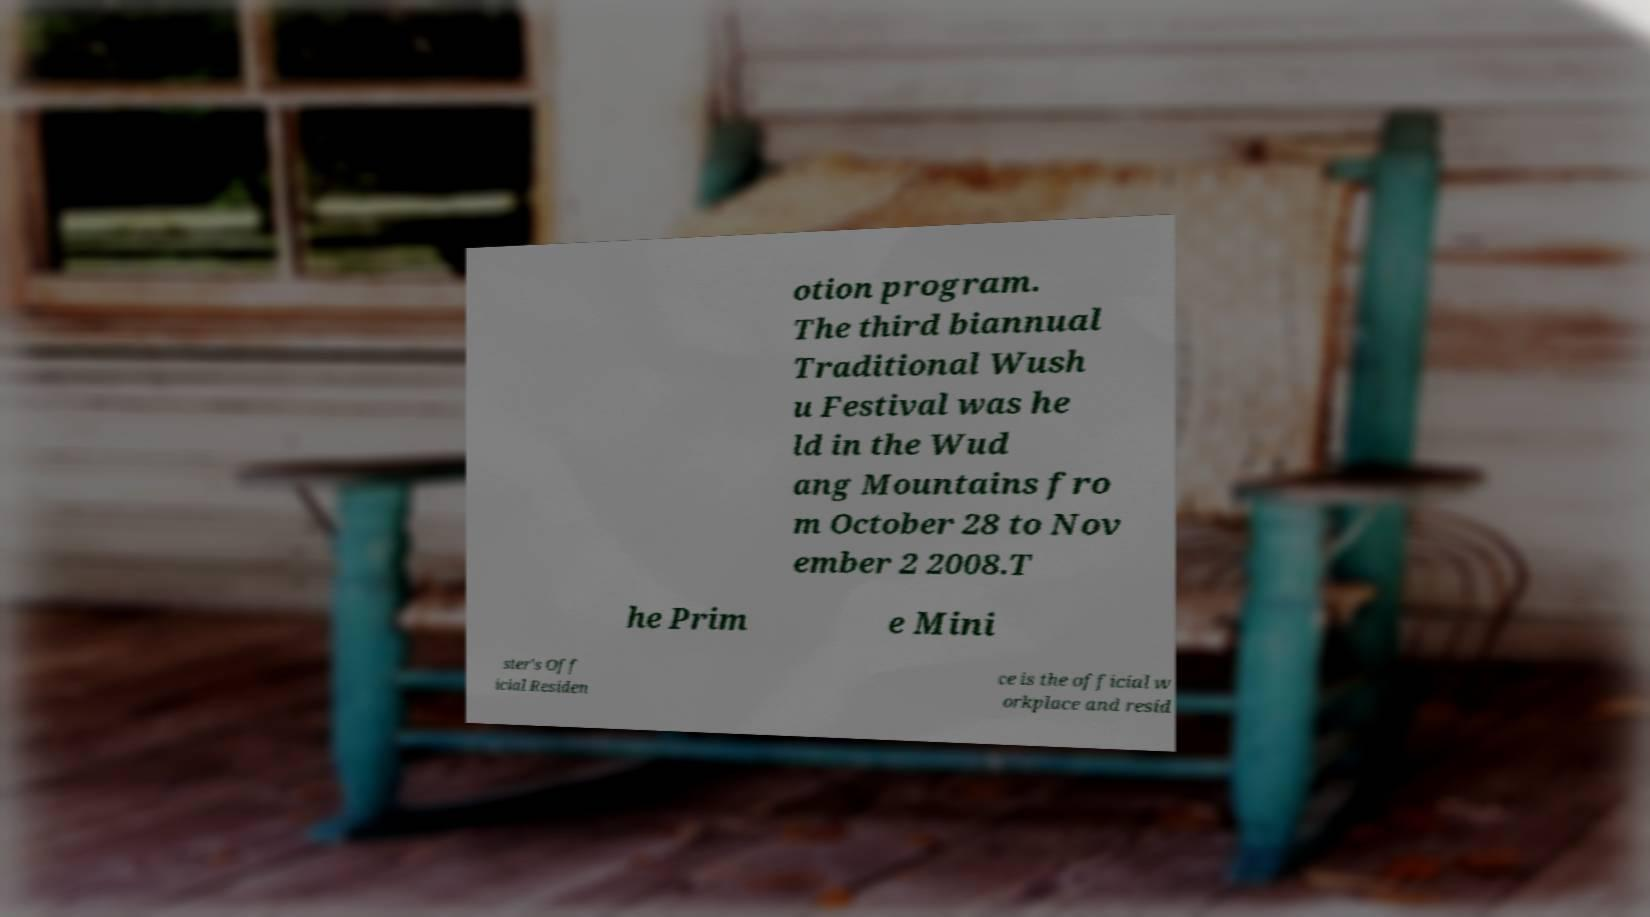Please identify and transcribe the text found in this image. otion program. The third biannual Traditional Wush u Festival was he ld in the Wud ang Mountains fro m October 28 to Nov ember 2 2008.T he Prim e Mini ster's Off icial Residen ce is the official w orkplace and resid 